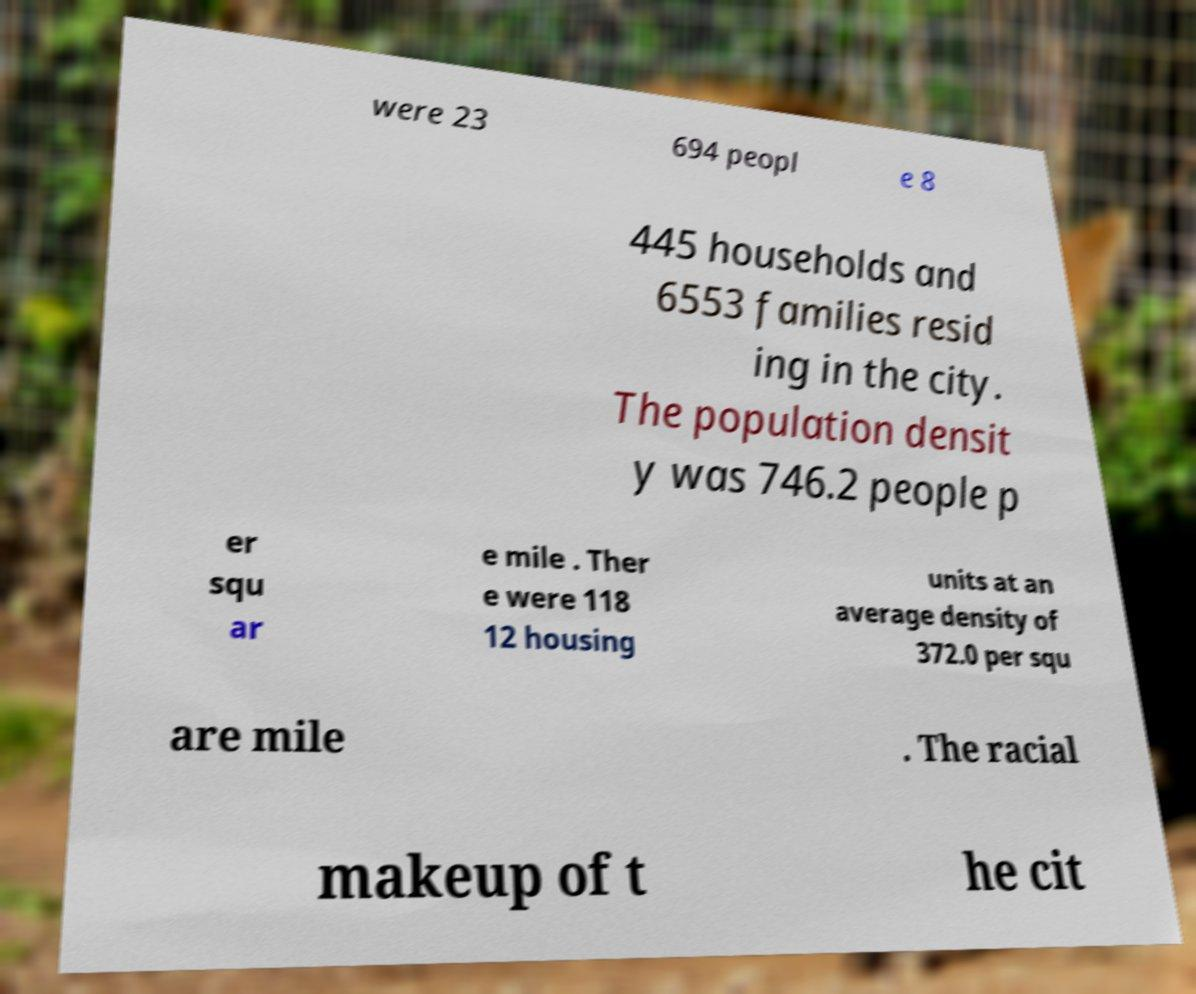Could you extract and type out the text from this image? were 23 694 peopl e 8 445 households and 6553 families resid ing in the city. The population densit y was 746.2 people p er squ ar e mile . Ther e were 118 12 housing units at an average density of 372.0 per squ are mile . The racial makeup of t he cit 